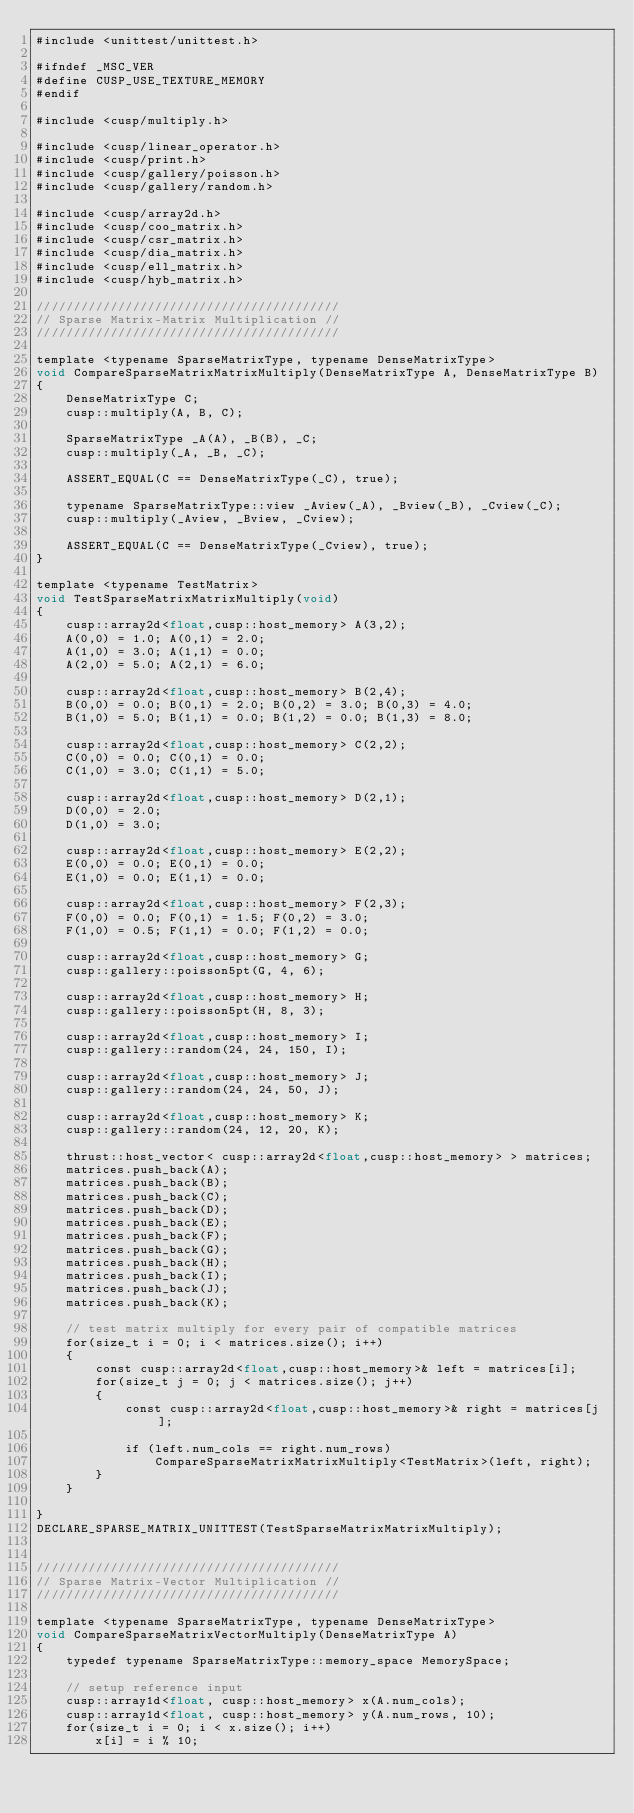<code> <loc_0><loc_0><loc_500><loc_500><_Cuda_>#include <unittest/unittest.h>

#ifndef _MSC_VER
#define CUSP_USE_TEXTURE_MEMORY
#endif

#include <cusp/multiply.h>

#include <cusp/linear_operator.h>
#include <cusp/print.h>
#include <cusp/gallery/poisson.h>
#include <cusp/gallery/random.h>

#include <cusp/array2d.h>
#include <cusp/coo_matrix.h>
#include <cusp/csr_matrix.h>
#include <cusp/dia_matrix.h>
#include <cusp/ell_matrix.h>
#include <cusp/hyb_matrix.h>

/////////////////////////////////////////
// Sparse Matrix-Matrix Multiplication //
/////////////////////////////////////////

template <typename SparseMatrixType, typename DenseMatrixType>
void CompareSparseMatrixMatrixMultiply(DenseMatrixType A, DenseMatrixType B)
{
    DenseMatrixType C;
    cusp::multiply(A, B, C);

    SparseMatrixType _A(A), _B(B), _C;
    cusp::multiply(_A, _B, _C);
    
    ASSERT_EQUAL(C == DenseMatrixType(_C), true);
    
    typename SparseMatrixType::view _Aview(_A), _Bview(_B), _Cview(_C);
    cusp::multiply(_Aview, _Bview, _Cview);
    
    ASSERT_EQUAL(C == DenseMatrixType(_Cview), true);
}

template <typename TestMatrix>
void TestSparseMatrixMatrixMultiply(void)
{
    cusp::array2d<float,cusp::host_memory> A(3,2);
    A(0,0) = 1.0; A(0,1) = 2.0;
    A(1,0) = 3.0; A(1,1) = 0.0;
    A(2,0) = 5.0; A(2,1) = 6.0;
    
    cusp::array2d<float,cusp::host_memory> B(2,4);
    B(0,0) = 0.0; B(0,1) = 2.0; B(0,2) = 3.0; B(0,3) = 4.0;
    B(1,0) = 5.0; B(1,1) = 0.0; B(1,2) = 0.0; B(1,3) = 8.0;

    cusp::array2d<float,cusp::host_memory> C(2,2);
    C(0,0) = 0.0; C(0,1) = 0.0;
    C(1,0) = 3.0; C(1,1) = 5.0;
    
    cusp::array2d<float,cusp::host_memory> D(2,1);
    D(0,0) = 2.0;
    D(1,0) = 3.0;
    
    cusp::array2d<float,cusp::host_memory> E(2,2);
    E(0,0) = 0.0; E(0,1) = 0.0;
    E(1,0) = 0.0; E(1,1) = 0.0;
    
    cusp::array2d<float,cusp::host_memory> F(2,3);
    F(0,0) = 0.0; F(0,1) = 1.5; F(0,2) = 3.0;
    F(1,0) = 0.5; F(1,1) = 0.0; F(1,2) = 0.0;
    
    cusp::array2d<float,cusp::host_memory> G;
    cusp::gallery::poisson5pt(G, 4, 6);

    cusp::array2d<float,cusp::host_memory> H;
    cusp::gallery::poisson5pt(H, 8, 3);

    cusp::array2d<float,cusp::host_memory> I;
    cusp::gallery::random(24, 24, 150, I);
    
    cusp::array2d<float,cusp::host_memory> J;
    cusp::gallery::random(24, 24, 50, J);

    cusp::array2d<float,cusp::host_memory> K;
    cusp::gallery::random(24, 12, 20, K);
 
    thrust::host_vector< cusp::array2d<float,cusp::host_memory> > matrices;
    matrices.push_back(A);
    matrices.push_back(B);
    matrices.push_back(C);
    matrices.push_back(D);
    matrices.push_back(E);
    matrices.push_back(F);
    matrices.push_back(G);
    matrices.push_back(H);
    matrices.push_back(I);
    matrices.push_back(J);
    matrices.push_back(K);

    // test matrix multiply for every pair of compatible matrices
    for(size_t i = 0; i < matrices.size(); i++)
    {
        const cusp::array2d<float,cusp::host_memory>& left = matrices[i];
        for(size_t j = 0; j < matrices.size(); j++)
        {
            const cusp::array2d<float,cusp::host_memory>& right = matrices[j];

            if (left.num_cols == right.num_rows)
                CompareSparseMatrixMatrixMultiply<TestMatrix>(left, right);
        }
    }

}
DECLARE_SPARSE_MATRIX_UNITTEST(TestSparseMatrixMatrixMultiply);


/////////////////////////////////////////
// Sparse Matrix-Vector Multiplication //
/////////////////////////////////////////

template <typename SparseMatrixType, typename DenseMatrixType>
void CompareSparseMatrixVectorMultiply(DenseMatrixType A)
{
    typedef typename SparseMatrixType::memory_space MemorySpace;

    // setup reference input
    cusp::array1d<float, cusp::host_memory> x(A.num_cols);
    cusp::array1d<float, cusp::host_memory> y(A.num_rows, 10);
    for(size_t i = 0; i < x.size(); i++)
        x[i] = i % 10;
</code> 